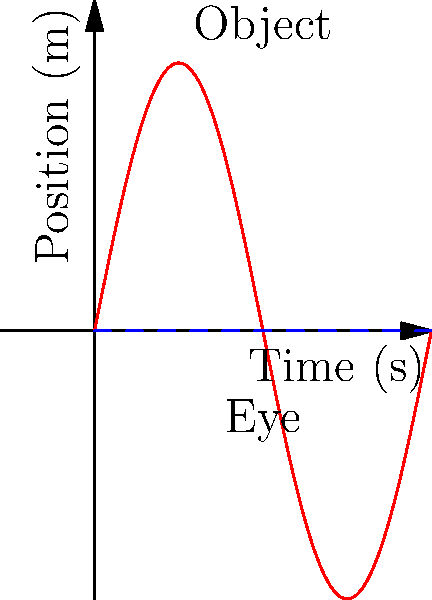Consider an object moving in a sinusoidal path as shown in the graph. If the eye attempts to track this object, what type of eye movement would be most effective, and why might this be challenging for someone with neurological vision problems? To effectively track the object, the eye needs to perform a combination of movements:

1. Smooth pursuit: This is the primary type of eye movement used for tracking moving objects. It allows the eyes to follow a moving target smoothly.

2. Saccades: These are rapid, jerky movements that help reposition the eye quickly when the object changes direction or speed.

3. Vestibulo-ocular reflex: This helps stabilize vision during head movements, which may occur as the person tries to follow the object.

The sinusoidal motion of the object presents specific challenges:

a) The object's velocity is constantly changing, requiring continuous adjustment of eye movement speed.

b) The direction reverses periodically, necessitating quick changes in eye movement direction.

c) The amplitude of motion varies, requiring adjustments in the range of eye movement.

For someone with neurological vision problems, this tracking task could be challenging because:

1) Smooth pursuit may be impaired, making it difficult to follow the continuous motion.

2) Saccade accuracy or speed might be affected, leading to delays in catching up with direction changes.

3) The constant need for adjustment may cause fatigue or strain more quickly.

4) Processing the complex motion pattern might be more difficult due to neurological issues affecting visual perception or eye-brain coordination.

5) Any issues with depth perception or spatial awareness could make interpreting the 2D motion in 3D space more challenging.
Answer: Smooth pursuit with saccadic corrections 